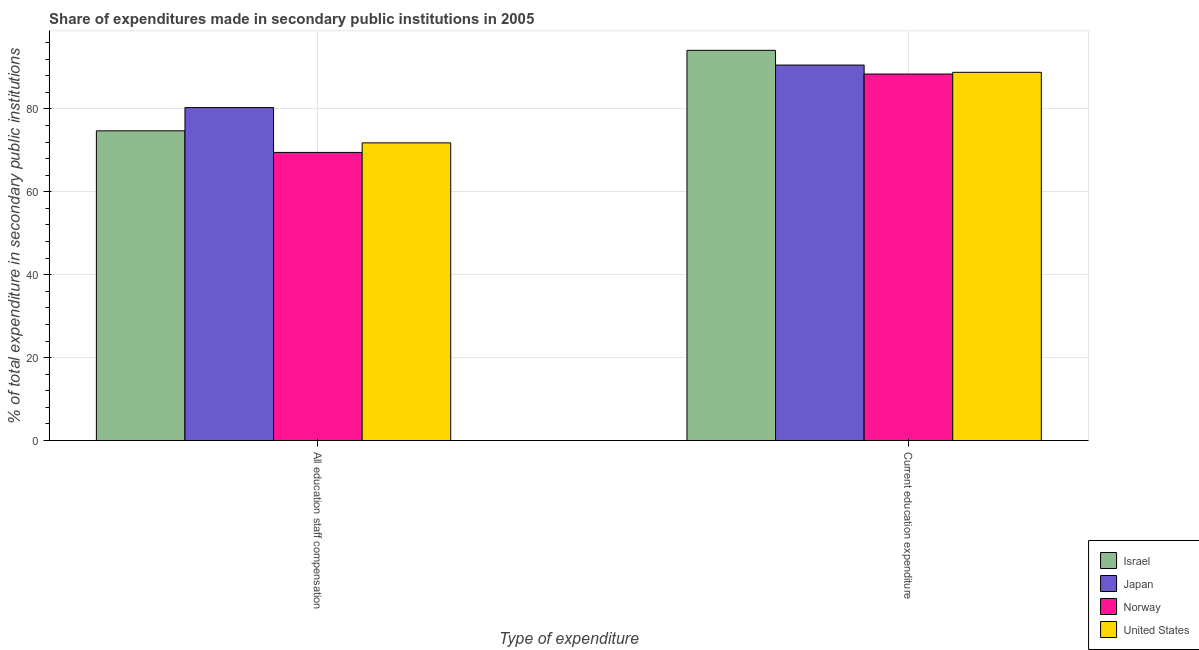How many different coloured bars are there?
Offer a terse response. 4. Are the number of bars per tick equal to the number of legend labels?
Make the answer very short. Yes. What is the label of the 1st group of bars from the left?
Provide a short and direct response. All education staff compensation. What is the expenditure in staff compensation in Israel?
Offer a very short reply. 74.7. Across all countries, what is the maximum expenditure in education?
Ensure brevity in your answer.  94.11. Across all countries, what is the minimum expenditure in staff compensation?
Your answer should be compact. 69.49. In which country was the expenditure in staff compensation maximum?
Provide a succinct answer. Japan. What is the total expenditure in education in the graph?
Provide a short and direct response. 361.87. What is the difference between the expenditure in staff compensation in Japan and that in United States?
Keep it short and to the point. 8.51. What is the difference between the expenditure in staff compensation in Japan and the expenditure in education in Israel?
Give a very brief answer. -13.81. What is the average expenditure in staff compensation per country?
Your answer should be compact. 74.07. What is the difference between the expenditure in staff compensation and expenditure in education in Norway?
Provide a succinct answer. -18.9. In how many countries, is the expenditure in staff compensation greater than 80 %?
Your answer should be very brief. 1. What is the ratio of the expenditure in education in Japan to that in Norway?
Offer a very short reply. 1.02. What does the 4th bar from the left in All education staff compensation represents?
Provide a succinct answer. United States. How many bars are there?
Provide a short and direct response. 8. Are all the bars in the graph horizontal?
Provide a succinct answer. No. Does the graph contain any zero values?
Your answer should be compact. No. How many legend labels are there?
Your response must be concise. 4. How are the legend labels stacked?
Provide a short and direct response. Vertical. What is the title of the graph?
Offer a very short reply. Share of expenditures made in secondary public institutions in 2005. What is the label or title of the X-axis?
Your answer should be very brief. Type of expenditure. What is the label or title of the Y-axis?
Make the answer very short. % of total expenditure in secondary public institutions. What is the % of total expenditure in secondary public institutions of Israel in All education staff compensation?
Ensure brevity in your answer.  74.7. What is the % of total expenditure in secondary public institutions in Japan in All education staff compensation?
Provide a succinct answer. 80.3. What is the % of total expenditure in secondary public institutions of Norway in All education staff compensation?
Keep it short and to the point. 69.49. What is the % of total expenditure in secondary public institutions in United States in All education staff compensation?
Your answer should be compact. 71.79. What is the % of total expenditure in secondary public institutions in Israel in Current education expenditure?
Offer a very short reply. 94.11. What is the % of total expenditure in secondary public institutions of Japan in Current education expenditure?
Your answer should be very brief. 90.56. What is the % of total expenditure in secondary public institutions of Norway in Current education expenditure?
Offer a terse response. 88.39. What is the % of total expenditure in secondary public institutions in United States in Current education expenditure?
Your response must be concise. 88.81. Across all Type of expenditure, what is the maximum % of total expenditure in secondary public institutions of Israel?
Your response must be concise. 94.11. Across all Type of expenditure, what is the maximum % of total expenditure in secondary public institutions of Japan?
Provide a succinct answer. 90.56. Across all Type of expenditure, what is the maximum % of total expenditure in secondary public institutions of Norway?
Ensure brevity in your answer.  88.39. Across all Type of expenditure, what is the maximum % of total expenditure in secondary public institutions in United States?
Your answer should be very brief. 88.81. Across all Type of expenditure, what is the minimum % of total expenditure in secondary public institutions in Israel?
Provide a succinct answer. 74.7. Across all Type of expenditure, what is the minimum % of total expenditure in secondary public institutions of Japan?
Your answer should be very brief. 80.3. Across all Type of expenditure, what is the minimum % of total expenditure in secondary public institutions in Norway?
Your answer should be compact. 69.49. Across all Type of expenditure, what is the minimum % of total expenditure in secondary public institutions in United States?
Make the answer very short. 71.79. What is the total % of total expenditure in secondary public institutions in Israel in the graph?
Your answer should be compact. 168.81. What is the total % of total expenditure in secondary public institutions of Japan in the graph?
Your answer should be compact. 170.86. What is the total % of total expenditure in secondary public institutions of Norway in the graph?
Offer a terse response. 157.89. What is the total % of total expenditure in secondary public institutions of United States in the graph?
Make the answer very short. 160.6. What is the difference between the % of total expenditure in secondary public institutions of Israel in All education staff compensation and that in Current education expenditure?
Keep it short and to the point. -19.41. What is the difference between the % of total expenditure in secondary public institutions of Japan in All education staff compensation and that in Current education expenditure?
Make the answer very short. -10.25. What is the difference between the % of total expenditure in secondary public institutions in Norway in All education staff compensation and that in Current education expenditure?
Offer a terse response. -18.9. What is the difference between the % of total expenditure in secondary public institutions of United States in All education staff compensation and that in Current education expenditure?
Your answer should be very brief. -17.01. What is the difference between the % of total expenditure in secondary public institutions of Israel in All education staff compensation and the % of total expenditure in secondary public institutions of Japan in Current education expenditure?
Provide a succinct answer. -15.86. What is the difference between the % of total expenditure in secondary public institutions in Israel in All education staff compensation and the % of total expenditure in secondary public institutions in Norway in Current education expenditure?
Your response must be concise. -13.7. What is the difference between the % of total expenditure in secondary public institutions of Israel in All education staff compensation and the % of total expenditure in secondary public institutions of United States in Current education expenditure?
Give a very brief answer. -14.11. What is the difference between the % of total expenditure in secondary public institutions of Japan in All education staff compensation and the % of total expenditure in secondary public institutions of Norway in Current education expenditure?
Provide a short and direct response. -8.09. What is the difference between the % of total expenditure in secondary public institutions in Japan in All education staff compensation and the % of total expenditure in secondary public institutions in United States in Current education expenditure?
Provide a succinct answer. -8.5. What is the difference between the % of total expenditure in secondary public institutions of Norway in All education staff compensation and the % of total expenditure in secondary public institutions of United States in Current education expenditure?
Offer a terse response. -19.31. What is the average % of total expenditure in secondary public institutions of Israel per Type of expenditure?
Offer a very short reply. 84.4. What is the average % of total expenditure in secondary public institutions in Japan per Type of expenditure?
Your response must be concise. 85.43. What is the average % of total expenditure in secondary public institutions of Norway per Type of expenditure?
Your answer should be compact. 78.94. What is the average % of total expenditure in secondary public institutions in United States per Type of expenditure?
Your answer should be very brief. 80.3. What is the difference between the % of total expenditure in secondary public institutions in Israel and % of total expenditure in secondary public institutions in Japan in All education staff compensation?
Your response must be concise. -5.6. What is the difference between the % of total expenditure in secondary public institutions of Israel and % of total expenditure in secondary public institutions of Norway in All education staff compensation?
Offer a very short reply. 5.2. What is the difference between the % of total expenditure in secondary public institutions in Israel and % of total expenditure in secondary public institutions in United States in All education staff compensation?
Provide a short and direct response. 2.9. What is the difference between the % of total expenditure in secondary public institutions of Japan and % of total expenditure in secondary public institutions of Norway in All education staff compensation?
Your response must be concise. 10.81. What is the difference between the % of total expenditure in secondary public institutions in Japan and % of total expenditure in secondary public institutions in United States in All education staff compensation?
Give a very brief answer. 8.51. What is the difference between the % of total expenditure in secondary public institutions of Norway and % of total expenditure in secondary public institutions of United States in All education staff compensation?
Offer a terse response. -2.3. What is the difference between the % of total expenditure in secondary public institutions of Israel and % of total expenditure in secondary public institutions of Japan in Current education expenditure?
Provide a short and direct response. 3.55. What is the difference between the % of total expenditure in secondary public institutions in Israel and % of total expenditure in secondary public institutions in Norway in Current education expenditure?
Ensure brevity in your answer.  5.71. What is the difference between the % of total expenditure in secondary public institutions in Israel and % of total expenditure in secondary public institutions in United States in Current education expenditure?
Provide a short and direct response. 5.3. What is the difference between the % of total expenditure in secondary public institutions in Japan and % of total expenditure in secondary public institutions in Norway in Current education expenditure?
Your answer should be compact. 2.16. What is the difference between the % of total expenditure in secondary public institutions of Japan and % of total expenditure in secondary public institutions of United States in Current education expenditure?
Offer a terse response. 1.75. What is the difference between the % of total expenditure in secondary public institutions in Norway and % of total expenditure in secondary public institutions in United States in Current education expenditure?
Provide a short and direct response. -0.41. What is the ratio of the % of total expenditure in secondary public institutions in Israel in All education staff compensation to that in Current education expenditure?
Provide a succinct answer. 0.79. What is the ratio of the % of total expenditure in secondary public institutions of Japan in All education staff compensation to that in Current education expenditure?
Your answer should be compact. 0.89. What is the ratio of the % of total expenditure in secondary public institutions of Norway in All education staff compensation to that in Current education expenditure?
Your response must be concise. 0.79. What is the ratio of the % of total expenditure in secondary public institutions in United States in All education staff compensation to that in Current education expenditure?
Make the answer very short. 0.81. What is the difference between the highest and the second highest % of total expenditure in secondary public institutions in Israel?
Provide a short and direct response. 19.41. What is the difference between the highest and the second highest % of total expenditure in secondary public institutions in Japan?
Your answer should be compact. 10.25. What is the difference between the highest and the second highest % of total expenditure in secondary public institutions in Norway?
Give a very brief answer. 18.9. What is the difference between the highest and the second highest % of total expenditure in secondary public institutions in United States?
Provide a short and direct response. 17.01. What is the difference between the highest and the lowest % of total expenditure in secondary public institutions of Israel?
Your answer should be very brief. 19.41. What is the difference between the highest and the lowest % of total expenditure in secondary public institutions of Japan?
Keep it short and to the point. 10.25. What is the difference between the highest and the lowest % of total expenditure in secondary public institutions in Norway?
Your answer should be compact. 18.9. What is the difference between the highest and the lowest % of total expenditure in secondary public institutions in United States?
Your answer should be very brief. 17.01. 